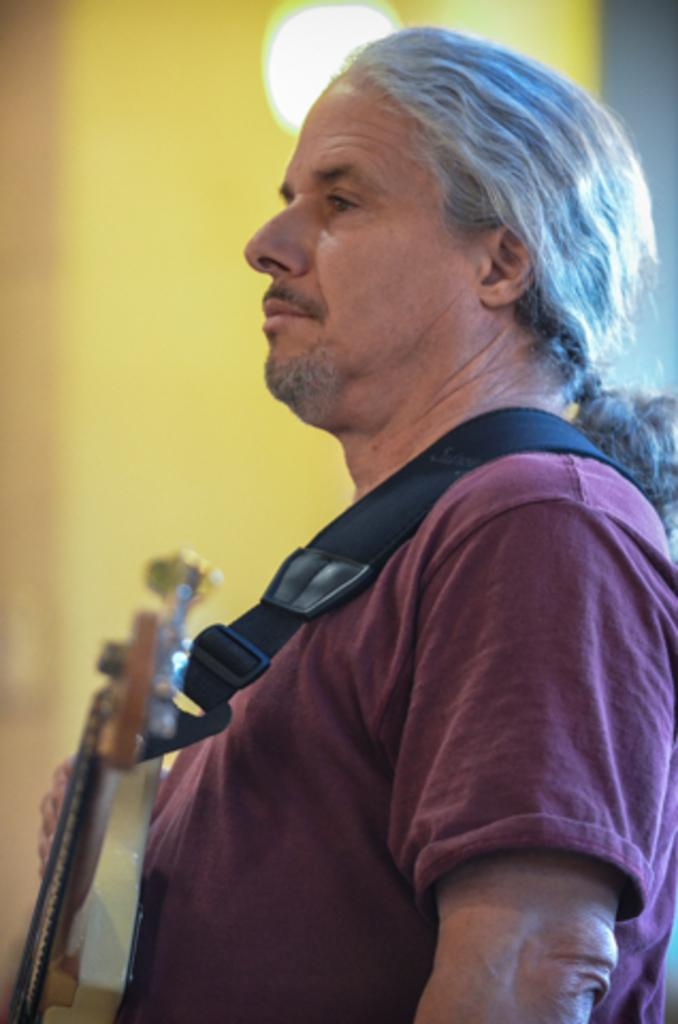Who is present in the image? There is a man in the image. What is the man wearing? The man is wearing a t-shirt. What object is the man holding? The man is holding a guitar. Can you describe the lighting in the image? There is a light visible in the image. How many girls are present in the image? There are no girls present in the image; it features a man holding a guitar. What type of pest can be seen crawling on the man's t-shirt in the image? There are no pests visible in the image; it only shows a man wearing a t-shirt and holding a guitar. 